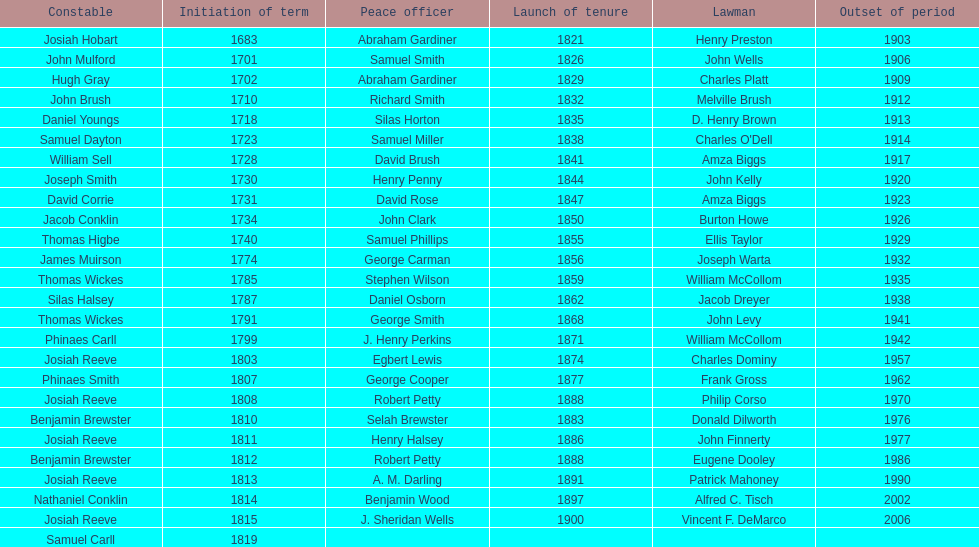What is the number of sheriff's with the last name smith? 5. 